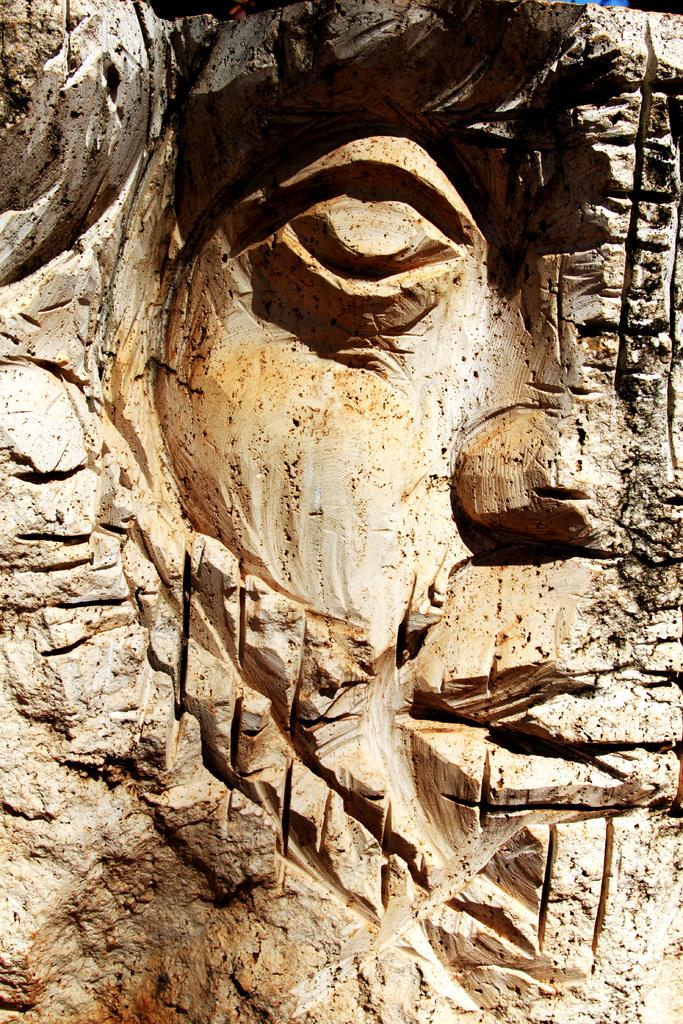What is the main subject of the image? The main subject of the image is a carving on a stone. Can you describe the carving in more detail? Unfortunately, the facts provided do not give any additional details about the carving. What type of material is the carving on? The carving is on a stone, as mentioned in the facts. Where is the spy hiding in the image? There is no mention of a spy in the image, so we cannot determine where a spy might be hiding. 